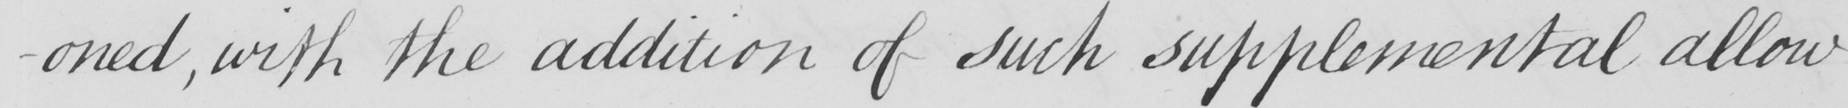Please transcribe the handwritten text in this image. -oned , with the addition of such supplemental allow- 